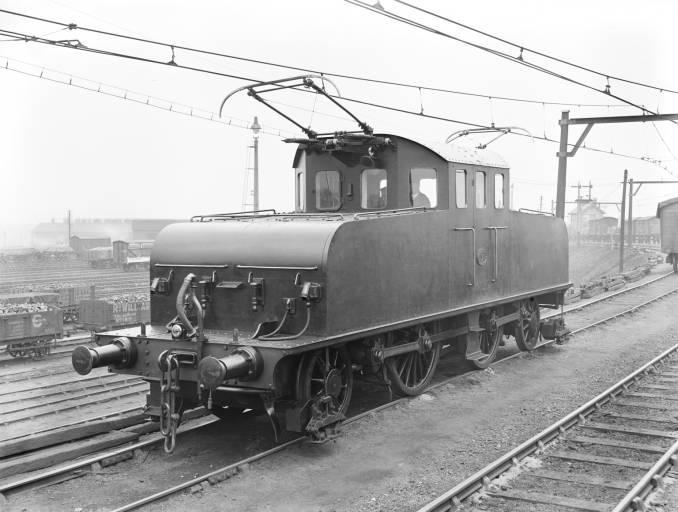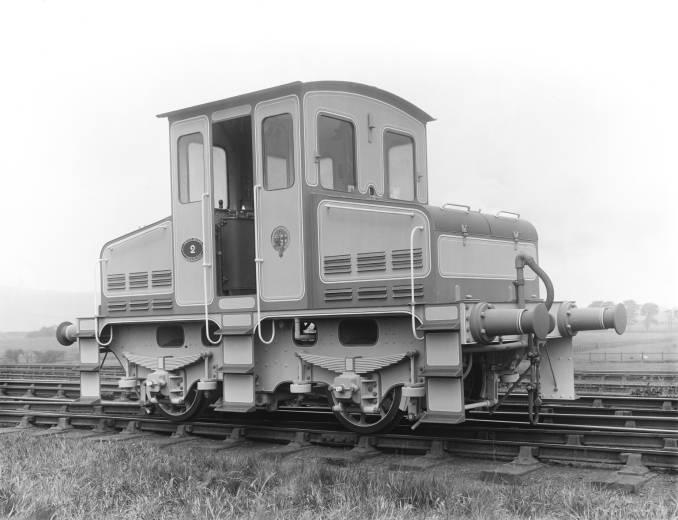The first image is the image on the left, the second image is the image on the right. For the images displayed, is the sentence "in the image pair the trains are facing each other" factually correct? Answer yes or no. No. The first image is the image on the left, the second image is the image on the right. For the images shown, is this caption "There is one image with a full train pointing to the right." true? Answer yes or no. No. 